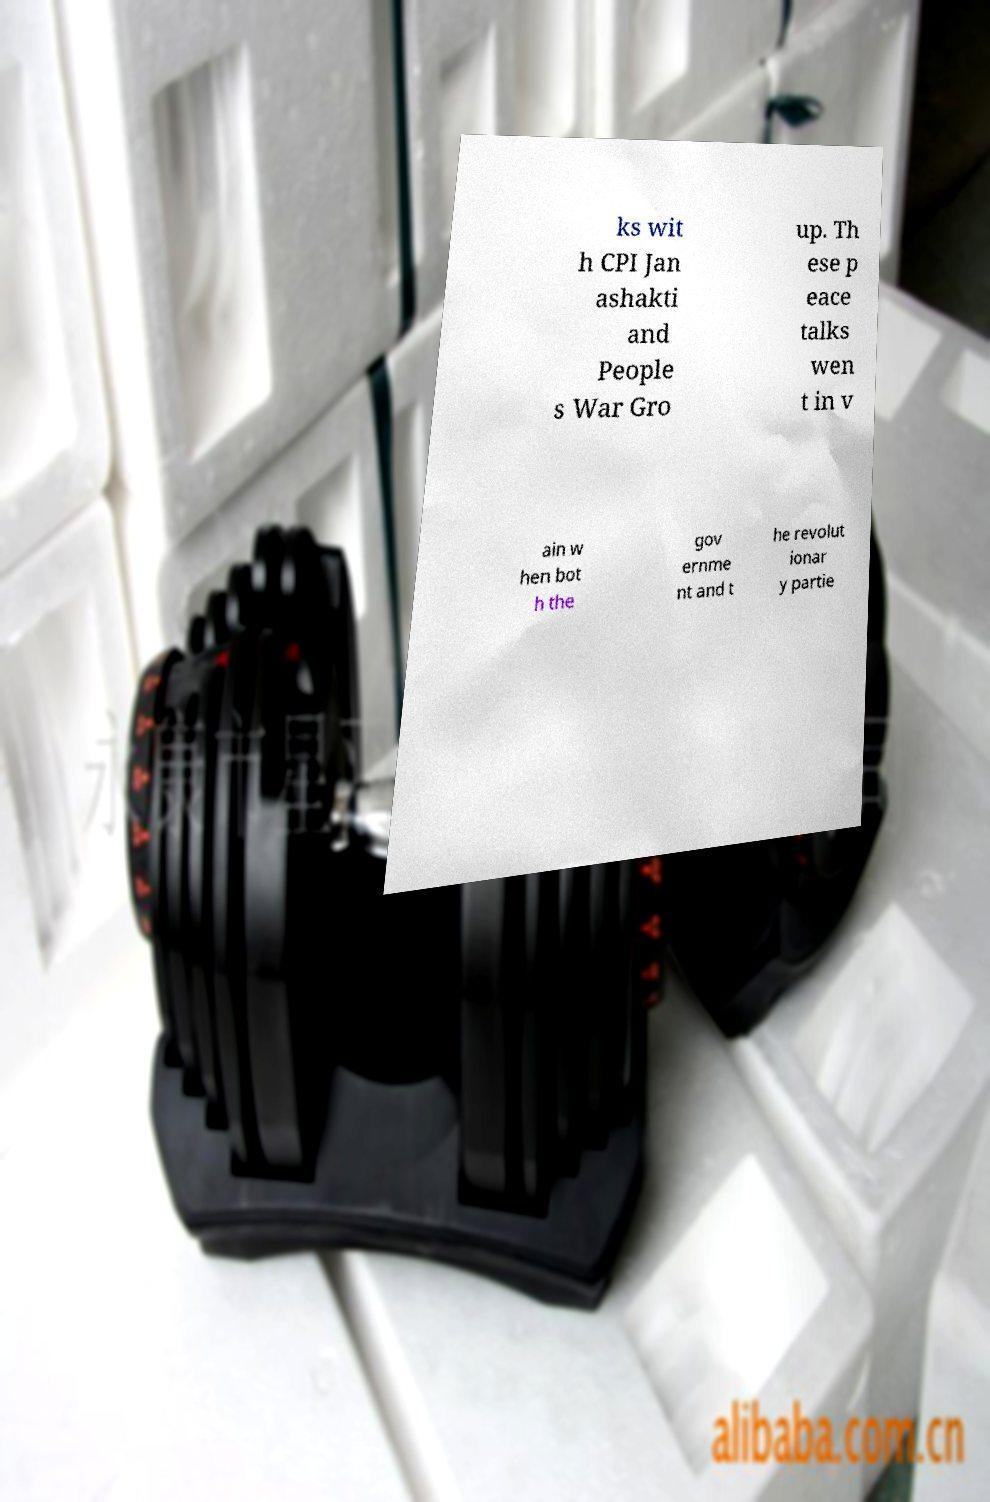What messages or text are displayed in this image? I need them in a readable, typed format. ks wit h CPI Jan ashakti and People s War Gro up. Th ese p eace talks wen t in v ain w hen bot h the gov ernme nt and t he revolut ionar y partie 